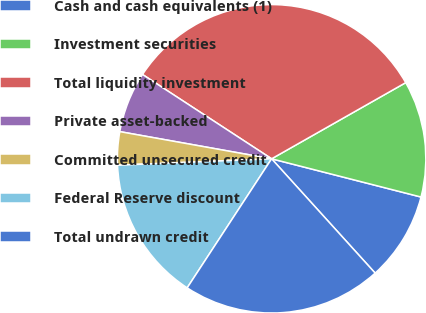Convert chart to OTSL. <chart><loc_0><loc_0><loc_500><loc_500><pie_chart><fcel>Cash and cash equivalents (1)<fcel>Investment securities<fcel>Total liquidity investment<fcel>Private asset-backed<fcel>Committed unsecured credit<fcel>Federal Reserve discount<fcel>Total undrawn credit<nl><fcel>9.3%<fcel>12.21%<fcel>32.58%<fcel>6.39%<fcel>3.48%<fcel>15.12%<fcel>20.94%<nl></chart> 